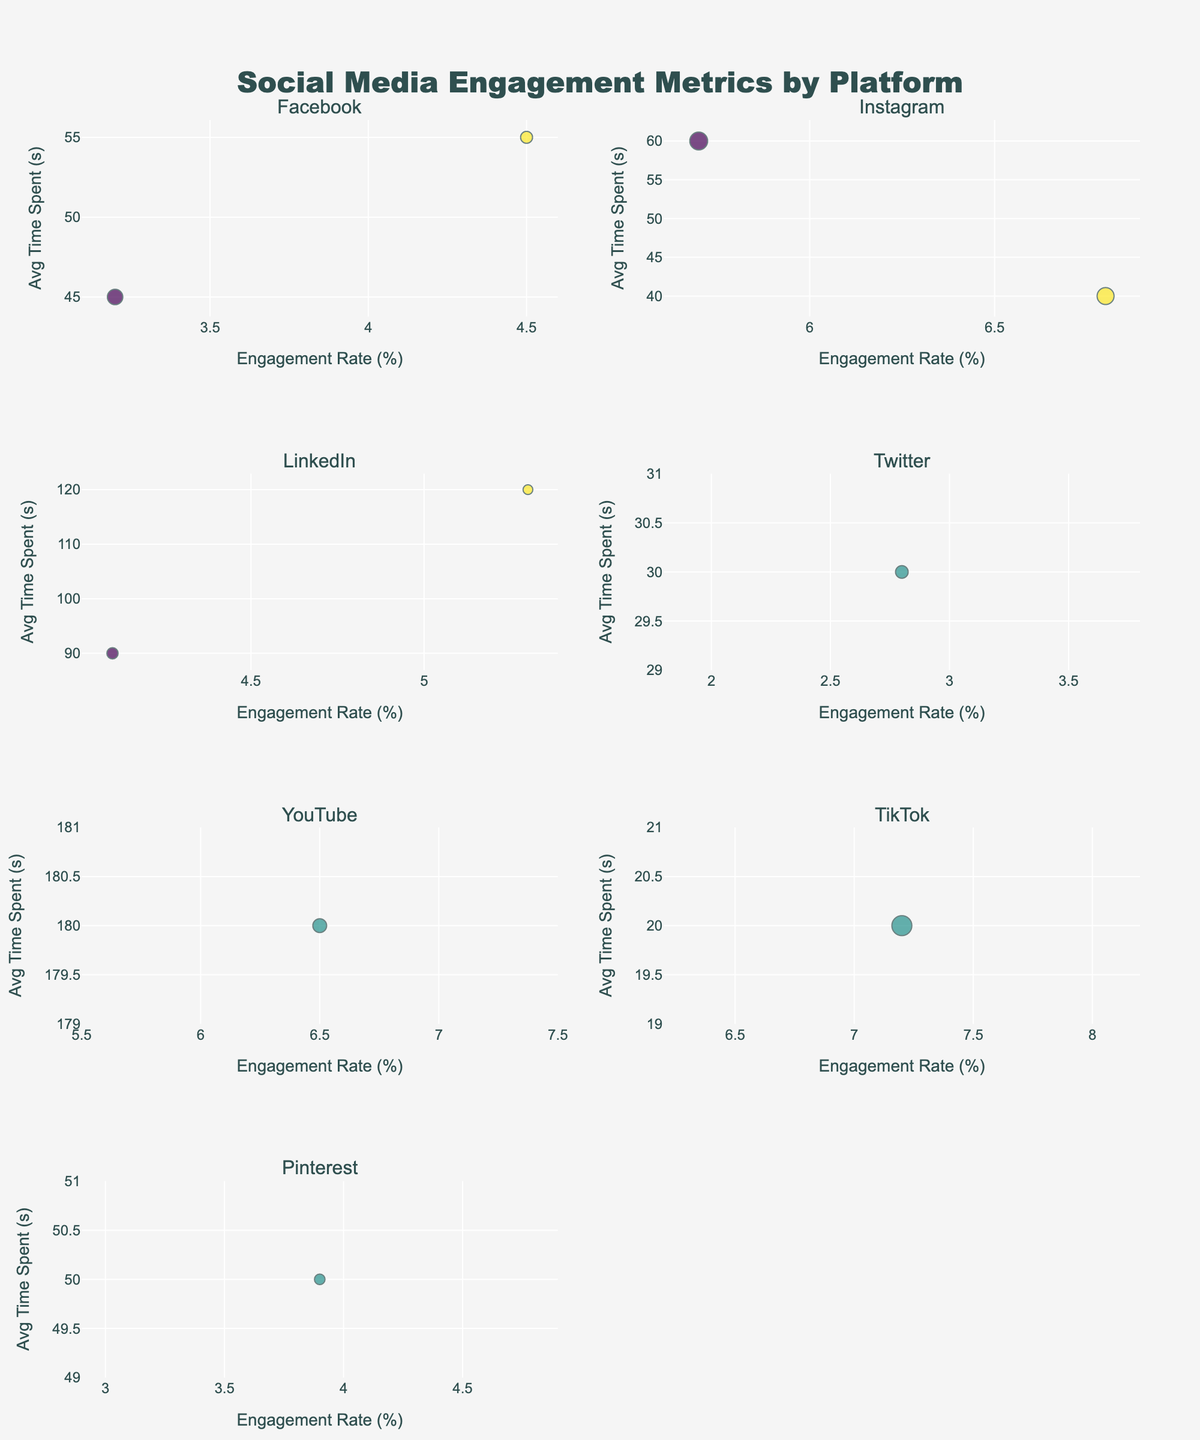Which platform has the highest average time spent? We identify each platform's subplot and check for their highest y-axis value (Average Time Spent). LinkedIn has the highest, as it reaches up to 120 seconds on the y-axis.
Answer: LinkedIn What type of content has the highest engagement rate on TikTok? We locate TikTok's subplot and find the data point on the x-axis with the highest value (Engagement Rate). The content type associated with this value is shown as "Behind-the-Scenes."
Answer: Behind-the-Scenes Which platform shows the smallest bubble? We look for the subplot where the bubble's size is the smallest visually. Pinterest, with one bubble related to "Infographics," appears to have the smallest bubble size, indicating fewer impressions.
Answer: Pinterest Which platform's content type 'Leadership Articles' belongs to? We identify the subplot with data labeled "Leadership Articles." It is found within LinkedIn's subplot.
Answer: LinkedIn Rank the platforms from the highest to the lowest average engagement rate. By checking each subplot's x-axis values for all data points, we can order the platforms: TikTok (7.2), YouTube (6.5), Instagram (5.7; 6.8), LinkedIn (5.3; 4.1), Facebook (4.5; 3.2), Pinterest (3.9), and Twitter (2.8).
Answer: TikTok, YouTube, Instagram, LinkedIn, Facebook, Pinterest, Twitter Which platform has the most varied average time spent among its content types? We compare the range of y-axis values within each subplot. LinkedIn has values from 90 to 120, suggesting it has the most varied average time spent.
Answer: LinkedIn What is the engagement rate for 'Company News' content on Facebook? In Facebook's subplot, we locate the bubble labeled "Company News" on the x-axis, indicating the engagement rate, which is 3.2.
Answer: 3.2% Compare the engagement rate and average time spent for 'Tutorial Videos' on YouTube and 'Customer Stories' on Twitter. Which one is higher in both metrics? For YouTube's "Tutorial Videos," engagement rate is 6.5% and average time spent is 180s. For Twitter's "Customer Stories," engagement rate is 2.8% and average time spent is 30s. Both metrics are higher for YouTube.
Answer: YouTube Which platform has content with the highest number of impressions, and what is the specific content type? We check the bubble sizes and tooltips to identify the largest bubble. TikTok's "Behind-the-Scenes" content has the largest bubble, indicating the highest impressions (250,000).
Answer: TikTok, Behind-the-Scenes What is the engagement rate range shown in the figure? We check all subplots' x-axis values for the minimum and maximum engagement rate values: The minimum is 2.8% on Twitter, and the maximum is 7.2% on TikTok.
Answer: 2.8% to 7.2% 